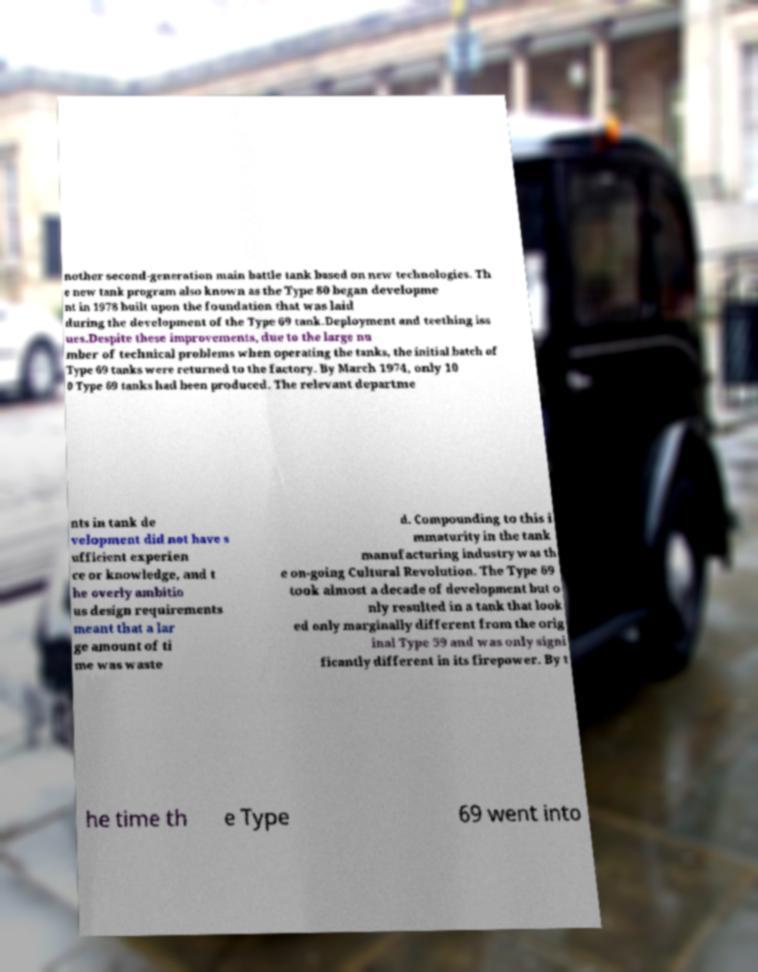Can you read and provide the text displayed in the image?This photo seems to have some interesting text. Can you extract and type it out for me? nother second-generation main battle tank based on new technologies. Th e new tank program also known as the Type 80 began developme nt in 1978 built upon the foundation that was laid during the development of the Type 69 tank.Deployment and teething iss ues.Despite these improvements, due to the large nu mber of technical problems when operating the tanks, the initial batch of Type 69 tanks were returned to the factory. By March 1974, only 10 0 Type 69 tanks had been produced. The relevant departme nts in tank de velopment did not have s ufficient experien ce or knowledge, and t he overly ambitio us design requirements meant that a lar ge amount of ti me was waste d. Compounding to this i mmaturity in the tank manufacturing industry was th e on-going Cultural Revolution. The Type 69 took almost a decade of development but o nly resulted in a tank that look ed only marginally different from the orig inal Type 59 and was only signi ficantly different in its firepower. By t he time th e Type 69 went into 